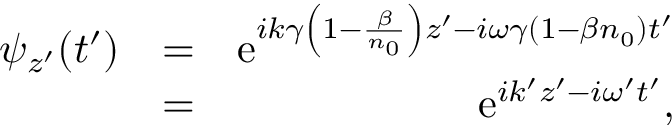Convert formula to latex. <formula><loc_0><loc_0><loc_500><loc_500>\begin{array} { r l r } { \psi _ { z ^ { \prime } } ( t ^ { \prime } ) } & { = } & { e ^ { i k \gamma \left ( 1 - \frac { \beta } { n _ { 0 } } \right ) z ^ { \prime } - i \omega \gamma \left ( 1 - \beta n _ { 0 } \right ) t ^ { \prime } } } \\ & { = } & { e ^ { i k ^ { \prime } z ^ { \prime } - i \omega ^ { \prime } t ^ { \prime } } , } \end{array}</formula> 